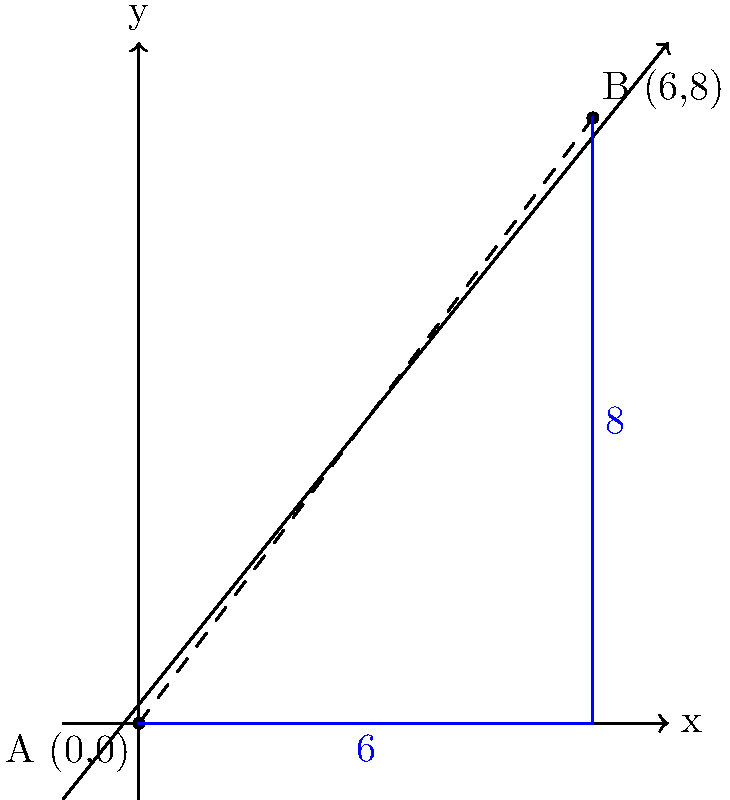In a memorable match between Alianza Lima and Universitario de Deportes, Juan Jayo (player A) is positioned at coordinates (0,0) on the field, while Nolberto Solano (player B) is at (6,8). Using the Cartesian plane to represent the field, calculate the direct distance between these two Peruvian football legends. Round your answer to two decimal places. To find the distance between two points on a Cartesian plane, we can use the distance formula, which is derived from the Pythagorean theorem:

$$d = \sqrt{(x_2-x_1)^2 + (y_2-y_1)^2}$$

Where $(x_1,y_1)$ are the coordinates of point A and $(x_2,y_2)$ are the coordinates of point B.

Given:
- Player A (Juan Jayo) is at (0,0)
- Player B (Nolberto Solano) is at (6,8)

Let's plug these values into the formula:

$$\begin{align}
d &= \sqrt{(6-0)^2 + (8-0)^2} \\
&= \sqrt{6^2 + 8^2} \\
&= \sqrt{36 + 64} \\
&= \sqrt{100} \\
&= 10
\end{align}$$

The exact distance is 10 units. Since the question asks for the answer rounded to two decimal places, our final answer is 10.00.
Answer: 10.00 units 